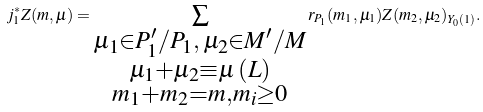<formula> <loc_0><loc_0><loc_500><loc_500>j _ { 1 } ^ { * } Z ( m , \mu ) = \sum _ { \substack { \mu _ { 1 } \in P _ { 1 } ^ { \prime } / P _ { 1 } , \, \mu _ { 2 } \in M ^ { \prime } / M \\ \mu _ { 1 } + \mu _ { 2 } \equiv \mu \, ( L ) \\ m _ { 1 } + m _ { 2 } = m , m _ { i } \geq 0 } } r _ { P _ { 1 } } ( m _ { 1 } , \mu _ { 1 } ) Z ( m _ { 2 } , \mu _ { 2 } ) _ { Y _ { 0 } ( 1 ) } .</formula> 